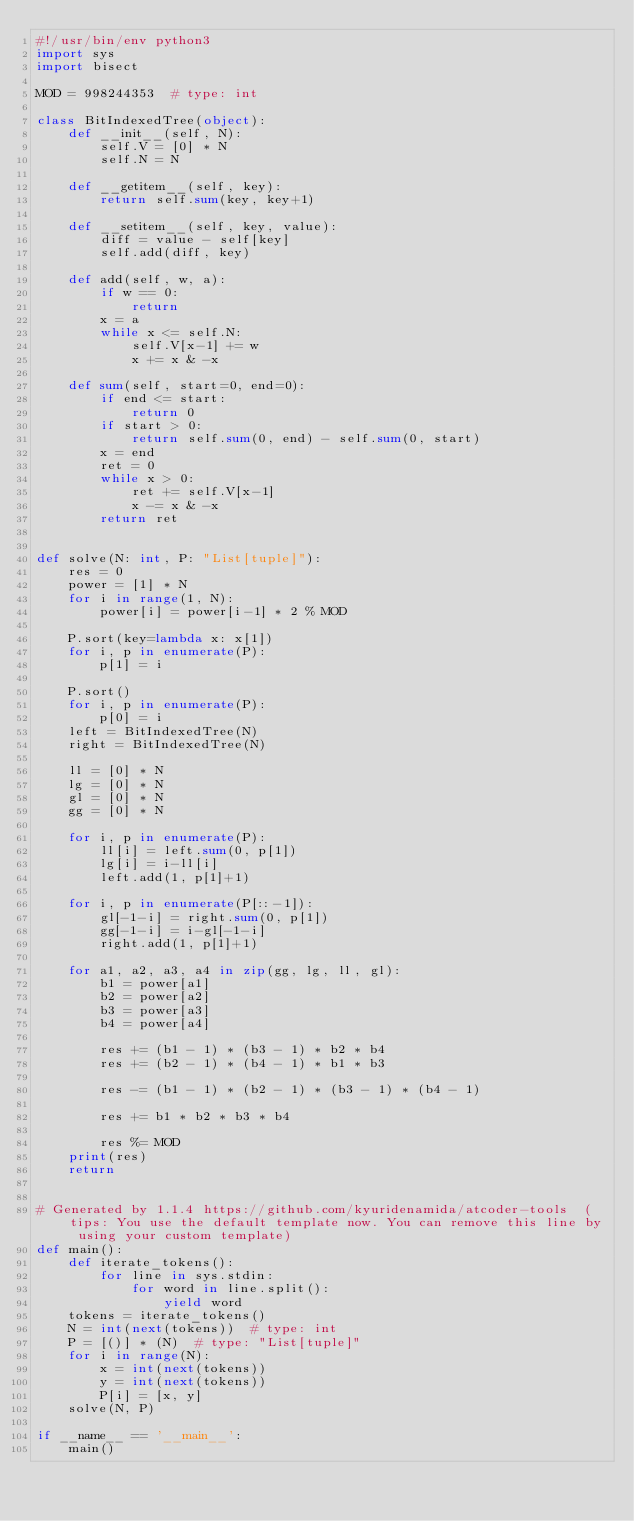Convert code to text. <code><loc_0><loc_0><loc_500><loc_500><_Python_>#!/usr/bin/env python3
import sys
import bisect

MOD = 998244353  # type: int

class BitIndexedTree(object):
    def __init__(self, N):
        self.V = [0] * N
        self.N = N
    
    def __getitem__(self, key):
        return self.sum(key, key+1)
    
    def __setitem__(self, key, value):
        diff = value - self[key]
        self.add(diff, key)

    def add(self, w, a):
        if w == 0:
            return
        x = a
        while x <= self.N:
            self.V[x-1] += w
            x += x & -x
    
    def sum(self, start=0, end=0):
        if end <= start:
            return 0
        if start > 0:
            return self.sum(0, end) - self.sum(0, start)
        x = end
        ret = 0
        while x > 0:
            ret += self.V[x-1]
            x -= x & -x
        return ret


def solve(N: int, P: "List[tuple]"):
    res = 0
    power = [1] * N
    for i in range(1, N):
        power[i] = power[i-1] * 2 % MOD

    P.sort(key=lambda x: x[1])
    for i, p in enumerate(P):
        p[1] = i
    
    P.sort()
    for i, p in enumerate(P):
        p[0] = i
    left = BitIndexedTree(N)
    right = BitIndexedTree(N)

    ll = [0] * N
    lg = [0] * N
    gl = [0] * N
    gg = [0] * N

    for i, p in enumerate(P):
        ll[i] = left.sum(0, p[1])
        lg[i] = i-ll[i]
        left.add(1, p[1]+1)

    for i, p in enumerate(P[::-1]):
        gl[-1-i] = right.sum(0, p[1])
        gg[-1-i] = i-gl[-1-i]
        right.add(1, p[1]+1)

    for a1, a2, a3, a4 in zip(gg, lg, ll, gl):
        b1 = power[a1]
        b2 = power[a2]
        b3 = power[a3]
        b4 = power[a4]

        res += (b1 - 1) * (b3 - 1) * b2 * b4
        res += (b2 - 1) * (b4 - 1) * b1 * b3

        res -= (b1 - 1) * (b2 - 1) * (b3 - 1) * (b4 - 1)

        res += b1 * b2 * b3 * b4

        res %= MOD
    print(res)
    return


# Generated by 1.1.4 https://github.com/kyuridenamida/atcoder-tools  (tips: You use the default template now. You can remove this line by using your custom template)
def main():
    def iterate_tokens():
        for line in sys.stdin:
            for word in line.split():
                yield word
    tokens = iterate_tokens()
    N = int(next(tokens))  # type: int
    P = [()] * (N)  # type: "List[tuple]" 
    for i in range(N):
        x = int(next(tokens))
        y = int(next(tokens))
        P[i] = [x, y]
    solve(N, P)

if __name__ == '__main__':
    main()
</code> 